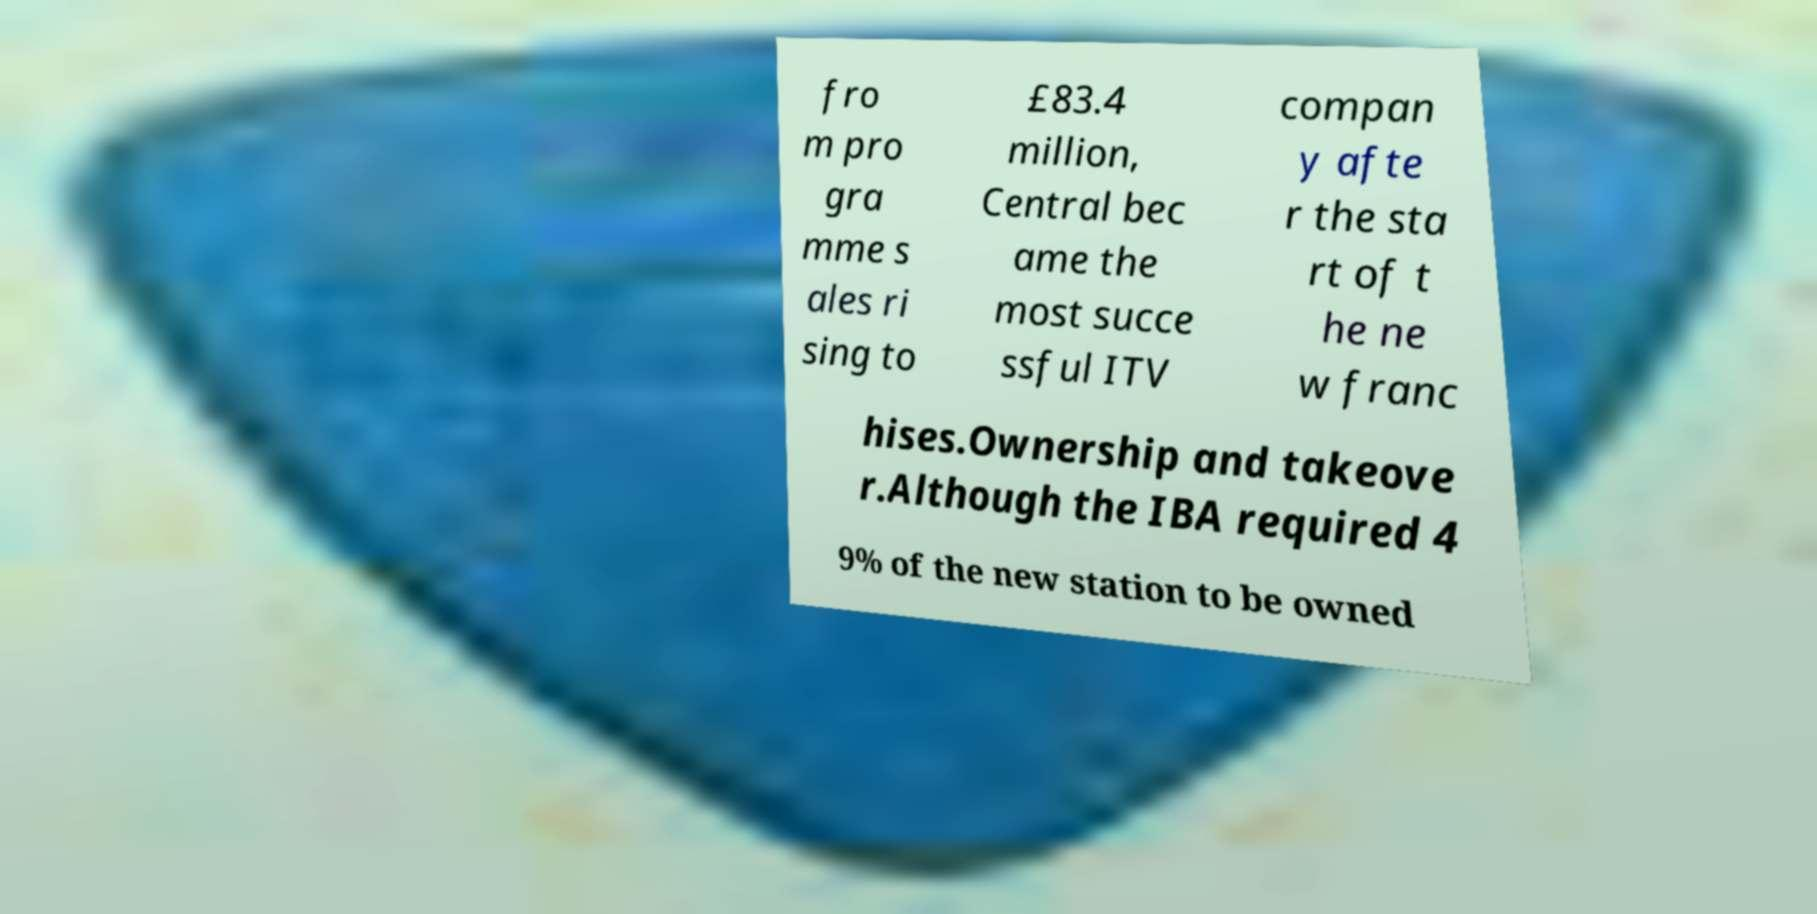Please read and relay the text visible in this image. What does it say? fro m pro gra mme s ales ri sing to £83.4 million, Central bec ame the most succe ssful ITV compan y afte r the sta rt of t he ne w franc hises.Ownership and takeove r.Although the IBA required 4 9% of the new station to be owned 